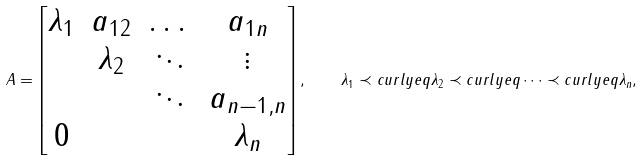Convert formula to latex. <formula><loc_0><loc_0><loc_500><loc_500>A = \begin{bmatrix} \lambda _ { 1 } & a _ { 1 2 } & \dots & a _ { 1 n } \\ & \lambda _ { 2 } & \ddots & \vdots \\ & & \ddots & a _ { n - 1 , n } \\ 0 & & & \lambda _ { n } \end{bmatrix} , \quad \lambda _ { 1 } \prec c u r l y e q \lambda _ { 2 } \prec c u r l y e q \dots \prec c u r l y e q \lambda _ { n } ,</formula> 